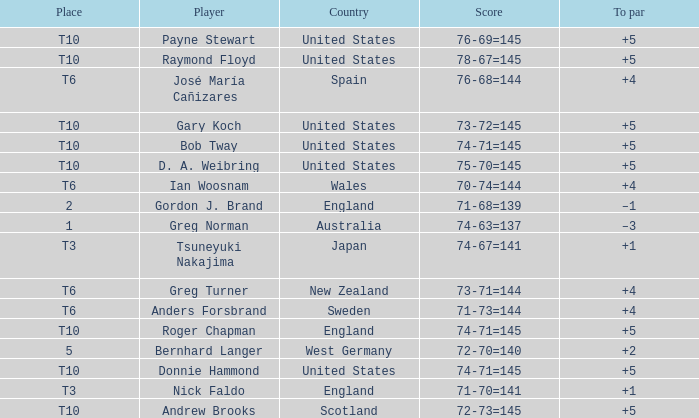What country did Raymond Floyd play for? United States. 